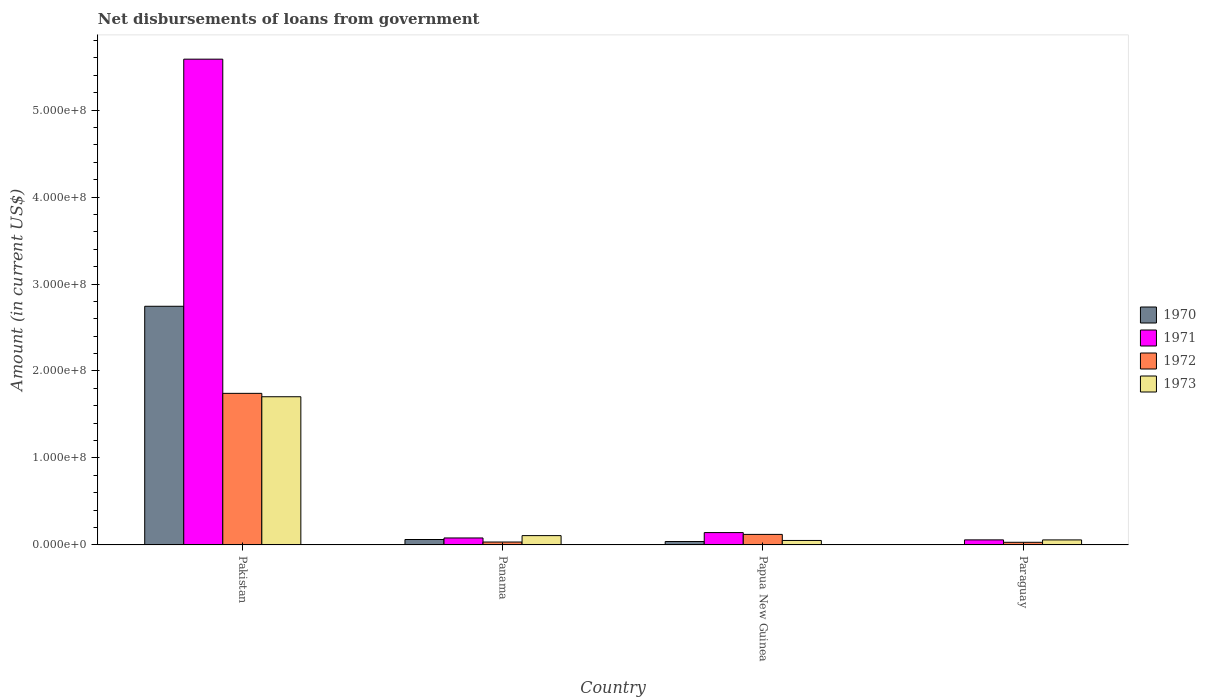How many different coloured bars are there?
Provide a short and direct response. 4. How many groups of bars are there?
Offer a terse response. 4. Are the number of bars on each tick of the X-axis equal?
Keep it short and to the point. Yes. What is the label of the 2nd group of bars from the left?
Provide a short and direct response. Panama. In how many cases, is the number of bars for a given country not equal to the number of legend labels?
Provide a succinct answer. 0. What is the amount of loan disbursed from government in 1970 in Pakistan?
Offer a terse response. 2.74e+08. Across all countries, what is the maximum amount of loan disbursed from government in 1970?
Provide a short and direct response. 2.74e+08. Across all countries, what is the minimum amount of loan disbursed from government in 1971?
Give a very brief answer. 5.80e+06. In which country was the amount of loan disbursed from government in 1971 maximum?
Make the answer very short. Pakistan. In which country was the amount of loan disbursed from government in 1973 minimum?
Provide a short and direct response. Papua New Guinea. What is the total amount of loan disbursed from government in 1973 in the graph?
Give a very brief answer. 1.92e+08. What is the difference between the amount of loan disbursed from government in 1972 in Panama and that in Papua New Guinea?
Your answer should be compact. -8.76e+06. What is the difference between the amount of loan disbursed from government in 1972 in Papua New Guinea and the amount of loan disbursed from government in 1973 in Pakistan?
Give a very brief answer. -1.58e+08. What is the average amount of loan disbursed from government in 1972 per country?
Your answer should be very brief. 4.82e+07. What is the difference between the amount of loan disbursed from government of/in 1970 and amount of loan disbursed from government of/in 1973 in Panama?
Provide a succinct answer. -4.46e+06. In how many countries, is the amount of loan disbursed from government in 1971 greater than 500000000 US$?
Make the answer very short. 1. What is the ratio of the amount of loan disbursed from government in 1971 in Pakistan to that in Paraguay?
Your response must be concise. 96.27. Is the amount of loan disbursed from government in 1970 in Pakistan less than that in Papua New Guinea?
Provide a short and direct response. No. What is the difference between the highest and the second highest amount of loan disbursed from government in 1970?
Provide a short and direct response. 2.70e+08. What is the difference between the highest and the lowest amount of loan disbursed from government in 1970?
Give a very brief answer. 2.74e+08. Is it the case that in every country, the sum of the amount of loan disbursed from government in 1972 and amount of loan disbursed from government in 1973 is greater than the sum of amount of loan disbursed from government in 1971 and amount of loan disbursed from government in 1970?
Your response must be concise. No. What does the 4th bar from the left in Pakistan represents?
Offer a terse response. 1973. Are all the bars in the graph horizontal?
Your answer should be compact. No. How many countries are there in the graph?
Make the answer very short. 4. Are the values on the major ticks of Y-axis written in scientific E-notation?
Provide a short and direct response. Yes. Does the graph contain grids?
Your answer should be very brief. No. Where does the legend appear in the graph?
Give a very brief answer. Center right. What is the title of the graph?
Your answer should be compact. Net disbursements of loans from government. What is the Amount (in current US$) of 1970 in Pakistan?
Offer a very short reply. 2.74e+08. What is the Amount (in current US$) in 1971 in Pakistan?
Provide a short and direct response. 5.59e+08. What is the Amount (in current US$) in 1972 in Pakistan?
Give a very brief answer. 1.74e+08. What is the Amount (in current US$) of 1973 in Pakistan?
Give a very brief answer. 1.70e+08. What is the Amount (in current US$) in 1970 in Panama?
Offer a very short reply. 6.24e+06. What is the Amount (in current US$) of 1971 in Panama?
Offer a terse response. 8.01e+06. What is the Amount (in current US$) in 1972 in Panama?
Ensure brevity in your answer.  3.34e+06. What is the Amount (in current US$) of 1973 in Panama?
Provide a short and direct response. 1.07e+07. What is the Amount (in current US$) in 1970 in Papua New Guinea?
Your answer should be compact. 3.92e+06. What is the Amount (in current US$) in 1971 in Papua New Guinea?
Keep it short and to the point. 1.42e+07. What is the Amount (in current US$) of 1972 in Papua New Guinea?
Your response must be concise. 1.21e+07. What is the Amount (in current US$) in 1973 in Papua New Guinea?
Provide a succinct answer. 5.14e+06. What is the Amount (in current US$) in 1970 in Paraguay?
Ensure brevity in your answer.  3.74e+05. What is the Amount (in current US$) in 1971 in Paraguay?
Give a very brief answer. 5.80e+06. What is the Amount (in current US$) of 1972 in Paraguay?
Your answer should be very brief. 3.04e+06. What is the Amount (in current US$) in 1973 in Paraguay?
Offer a terse response. 5.78e+06. Across all countries, what is the maximum Amount (in current US$) of 1970?
Offer a terse response. 2.74e+08. Across all countries, what is the maximum Amount (in current US$) of 1971?
Your answer should be very brief. 5.59e+08. Across all countries, what is the maximum Amount (in current US$) of 1972?
Provide a short and direct response. 1.74e+08. Across all countries, what is the maximum Amount (in current US$) in 1973?
Give a very brief answer. 1.70e+08. Across all countries, what is the minimum Amount (in current US$) of 1970?
Offer a very short reply. 3.74e+05. Across all countries, what is the minimum Amount (in current US$) in 1971?
Your response must be concise. 5.80e+06. Across all countries, what is the minimum Amount (in current US$) of 1972?
Give a very brief answer. 3.04e+06. Across all countries, what is the minimum Amount (in current US$) in 1973?
Make the answer very short. 5.14e+06. What is the total Amount (in current US$) in 1970 in the graph?
Your response must be concise. 2.85e+08. What is the total Amount (in current US$) in 1971 in the graph?
Offer a terse response. 5.87e+08. What is the total Amount (in current US$) of 1972 in the graph?
Make the answer very short. 1.93e+08. What is the total Amount (in current US$) of 1973 in the graph?
Offer a very short reply. 1.92e+08. What is the difference between the Amount (in current US$) of 1970 in Pakistan and that in Panama?
Offer a terse response. 2.68e+08. What is the difference between the Amount (in current US$) of 1971 in Pakistan and that in Panama?
Your response must be concise. 5.51e+08. What is the difference between the Amount (in current US$) in 1972 in Pakistan and that in Panama?
Ensure brevity in your answer.  1.71e+08. What is the difference between the Amount (in current US$) in 1973 in Pakistan and that in Panama?
Ensure brevity in your answer.  1.60e+08. What is the difference between the Amount (in current US$) in 1970 in Pakistan and that in Papua New Guinea?
Offer a very short reply. 2.70e+08. What is the difference between the Amount (in current US$) of 1971 in Pakistan and that in Papua New Guinea?
Your response must be concise. 5.44e+08. What is the difference between the Amount (in current US$) in 1972 in Pakistan and that in Papua New Guinea?
Provide a succinct answer. 1.62e+08. What is the difference between the Amount (in current US$) of 1973 in Pakistan and that in Papua New Guinea?
Offer a terse response. 1.65e+08. What is the difference between the Amount (in current US$) of 1970 in Pakistan and that in Paraguay?
Make the answer very short. 2.74e+08. What is the difference between the Amount (in current US$) of 1971 in Pakistan and that in Paraguay?
Ensure brevity in your answer.  5.53e+08. What is the difference between the Amount (in current US$) of 1972 in Pakistan and that in Paraguay?
Provide a succinct answer. 1.71e+08. What is the difference between the Amount (in current US$) in 1973 in Pakistan and that in Paraguay?
Offer a very short reply. 1.65e+08. What is the difference between the Amount (in current US$) of 1970 in Panama and that in Papua New Guinea?
Your answer should be compact. 2.32e+06. What is the difference between the Amount (in current US$) in 1971 in Panama and that in Papua New Guinea?
Ensure brevity in your answer.  -6.19e+06. What is the difference between the Amount (in current US$) in 1972 in Panama and that in Papua New Guinea?
Offer a terse response. -8.76e+06. What is the difference between the Amount (in current US$) in 1973 in Panama and that in Papua New Guinea?
Provide a succinct answer. 5.56e+06. What is the difference between the Amount (in current US$) in 1970 in Panama and that in Paraguay?
Make the answer very short. 5.87e+06. What is the difference between the Amount (in current US$) in 1971 in Panama and that in Paraguay?
Make the answer very short. 2.21e+06. What is the difference between the Amount (in current US$) of 1972 in Panama and that in Paraguay?
Provide a succinct answer. 3.09e+05. What is the difference between the Amount (in current US$) of 1973 in Panama and that in Paraguay?
Your response must be concise. 4.92e+06. What is the difference between the Amount (in current US$) in 1970 in Papua New Guinea and that in Paraguay?
Your answer should be compact. 3.55e+06. What is the difference between the Amount (in current US$) of 1971 in Papua New Guinea and that in Paraguay?
Your answer should be compact. 8.40e+06. What is the difference between the Amount (in current US$) in 1972 in Papua New Guinea and that in Paraguay?
Provide a short and direct response. 9.07e+06. What is the difference between the Amount (in current US$) in 1973 in Papua New Guinea and that in Paraguay?
Offer a very short reply. -6.38e+05. What is the difference between the Amount (in current US$) in 1970 in Pakistan and the Amount (in current US$) in 1971 in Panama?
Ensure brevity in your answer.  2.66e+08. What is the difference between the Amount (in current US$) in 1970 in Pakistan and the Amount (in current US$) in 1972 in Panama?
Provide a succinct answer. 2.71e+08. What is the difference between the Amount (in current US$) in 1970 in Pakistan and the Amount (in current US$) in 1973 in Panama?
Your answer should be compact. 2.64e+08. What is the difference between the Amount (in current US$) of 1971 in Pakistan and the Amount (in current US$) of 1972 in Panama?
Provide a short and direct response. 5.55e+08. What is the difference between the Amount (in current US$) of 1971 in Pakistan and the Amount (in current US$) of 1973 in Panama?
Offer a very short reply. 5.48e+08. What is the difference between the Amount (in current US$) of 1972 in Pakistan and the Amount (in current US$) of 1973 in Panama?
Offer a very short reply. 1.64e+08. What is the difference between the Amount (in current US$) in 1970 in Pakistan and the Amount (in current US$) in 1971 in Papua New Guinea?
Give a very brief answer. 2.60e+08. What is the difference between the Amount (in current US$) in 1970 in Pakistan and the Amount (in current US$) in 1972 in Papua New Guinea?
Your answer should be compact. 2.62e+08. What is the difference between the Amount (in current US$) in 1970 in Pakistan and the Amount (in current US$) in 1973 in Papua New Guinea?
Offer a terse response. 2.69e+08. What is the difference between the Amount (in current US$) in 1971 in Pakistan and the Amount (in current US$) in 1972 in Papua New Guinea?
Your response must be concise. 5.46e+08. What is the difference between the Amount (in current US$) of 1971 in Pakistan and the Amount (in current US$) of 1973 in Papua New Guinea?
Your answer should be compact. 5.53e+08. What is the difference between the Amount (in current US$) of 1972 in Pakistan and the Amount (in current US$) of 1973 in Papua New Guinea?
Offer a very short reply. 1.69e+08. What is the difference between the Amount (in current US$) in 1970 in Pakistan and the Amount (in current US$) in 1971 in Paraguay?
Your answer should be very brief. 2.69e+08. What is the difference between the Amount (in current US$) of 1970 in Pakistan and the Amount (in current US$) of 1972 in Paraguay?
Offer a terse response. 2.71e+08. What is the difference between the Amount (in current US$) in 1970 in Pakistan and the Amount (in current US$) in 1973 in Paraguay?
Your response must be concise. 2.69e+08. What is the difference between the Amount (in current US$) in 1971 in Pakistan and the Amount (in current US$) in 1972 in Paraguay?
Your answer should be very brief. 5.56e+08. What is the difference between the Amount (in current US$) in 1971 in Pakistan and the Amount (in current US$) in 1973 in Paraguay?
Provide a short and direct response. 5.53e+08. What is the difference between the Amount (in current US$) of 1972 in Pakistan and the Amount (in current US$) of 1973 in Paraguay?
Keep it short and to the point. 1.69e+08. What is the difference between the Amount (in current US$) of 1970 in Panama and the Amount (in current US$) of 1971 in Papua New Guinea?
Offer a terse response. -7.96e+06. What is the difference between the Amount (in current US$) of 1970 in Panama and the Amount (in current US$) of 1972 in Papua New Guinea?
Keep it short and to the point. -5.86e+06. What is the difference between the Amount (in current US$) in 1970 in Panama and the Amount (in current US$) in 1973 in Papua New Guinea?
Provide a short and direct response. 1.10e+06. What is the difference between the Amount (in current US$) in 1971 in Panama and the Amount (in current US$) in 1972 in Papua New Guinea?
Provide a short and direct response. -4.09e+06. What is the difference between the Amount (in current US$) of 1971 in Panama and the Amount (in current US$) of 1973 in Papua New Guinea?
Make the answer very short. 2.87e+06. What is the difference between the Amount (in current US$) of 1972 in Panama and the Amount (in current US$) of 1973 in Papua New Guinea?
Give a very brief answer. -1.79e+06. What is the difference between the Amount (in current US$) in 1970 in Panama and the Amount (in current US$) in 1972 in Paraguay?
Offer a terse response. 3.21e+06. What is the difference between the Amount (in current US$) of 1970 in Panama and the Amount (in current US$) of 1973 in Paraguay?
Provide a short and direct response. 4.65e+05. What is the difference between the Amount (in current US$) of 1971 in Panama and the Amount (in current US$) of 1972 in Paraguay?
Give a very brief answer. 4.97e+06. What is the difference between the Amount (in current US$) of 1971 in Panama and the Amount (in current US$) of 1973 in Paraguay?
Offer a terse response. 2.23e+06. What is the difference between the Amount (in current US$) of 1972 in Panama and the Amount (in current US$) of 1973 in Paraguay?
Your response must be concise. -2.43e+06. What is the difference between the Amount (in current US$) in 1970 in Papua New Guinea and the Amount (in current US$) in 1971 in Paraguay?
Give a very brief answer. -1.88e+06. What is the difference between the Amount (in current US$) of 1970 in Papua New Guinea and the Amount (in current US$) of 1972 in Paraguay?
Keep it short and to the point. 8.84e+05. What is the difference between the Amount (in current US$) in 1970 in Papua New Guinea and the Amount (in current US$) in 1973 in Paraguay?
Your response must be concise. -1.86e+06. What is the difference between the Amount (in current US$) in 1971 in Papua New Guinea and the Amount (in current US$) in 1972 in Paraguay?
Ensure brevity in your answer.  1.12e+07. What is the difference between the Amount (in current US$) of 1971 in Papua New Guinea and the Amount (in current US$) of 1973 in Paraguay?
Your answer should be very brief. 8.42e+06. What is the difference between the Amount (in current US$) of 1972 in Papua New Guinea and the Amount (in current US$) of 1973 in Paraguay?
Provide a short and direct response. 6.33e+06. What is the average Amount (in current US$) of 1970 per country?
Keep it short and to the point. 7.12e+07. What is the average Amount (in current US$) of 1971 per country?
Make the answer very short. 1.47e+08. What is the average Amount (in current US$) of 1972 per country?
Your answer should be very brief. 4.82e+07. What is the average Amount (in current US$) of 1973 per country?
Your answer should be very brief. 4.80e+07. What is the difference between the Amount (in current US$) in 1970 and Amount (in current US$) in 1971 in Pakistan?
Give a very brief answer. -2.84e+08. What is the difference between the Amount (in current US$) in 1970 and Amount (in current US$) in 1972 in Pakistan?
Make the answer very short. 1.00e+08. What is the difference between the Amount (in current US$) of 1970 and Amount (in current US$) of 1973 in Pakistan?
Offer a terse response. 1.04e+08. What is the difference between the Amount (in current US$) of 1971 and Amount (in current US$) of 1972 in Pakistan?
Make the answer very short. 3.84e+08. What is the difference between the Amount (in current US$) of 1971 and Amount (in current US$) of 1973 in Pakistan?
Provide a short and direct response. 3.88e+08. What is the difference between the Amount (in current US$) in 1972 and Amount (in current US$) in 1973 in Pakistan?
Ensure brevity in your answer.  3.90e+06. What is the difference between the Amount (in current US$) in 1970 and Amount (in current US$) in 1971 in Panama?
Provide a short and direct response. -1.77e+06. What is the difference between the Amount (in current US$) of 1970 and Amount (in current US$) of 1972 in Panama?
Your response must be concise. 2.90e+06. What is the difference between the Amount (in current US$) in 1970 and Amount (in current US$) in 1973 in Panama?
Provide a short and direct response. -4.46e+06. What is the difference between the Amount (in current US$) in 1971 and Amount (in current US$) in 1972 in Panama?
Your answer should be compact. 4.66e+06. What is the difference between the Amount (in current US$) in 1971 and Amount (in current US$) in 1973 in Panama?
Provide a short and direct response. -2.69e+06. What is the difference between the Amount (in current US$) in 1972 and Amount (in current US$) in 1973 in Panama?
Provide a short and direct response. -7.36e+06. What is the difference between the Amount (in current US$) in 1970 and Amount (in current US$) in 1971 in Papua New Guinea?
Keep it short and to the point. -1.03e+07. What is the difference between the Amount (in current US$) in 1970 and Amount (in current US$) in 1972 in Papua New Guinea?
Offer a very short reply. -8.18e+06. What is the difference between the Amount (in current US$) in 1970 and Amount (in current US$) in 1973 in Papua New Guinea?
Your answer should be compact. -1.22e+06. What is the difference between the Amount (in current US$) in 1971 and Amount (in current US$) in 1972 in Papua New Guinea?
Keep it short and to the point. 2.10e+06. What is the difference between the Amount (in current US$) in 1971 and Amount (in current US$) in 1973 in Papua New Guinea?
Make the answer very short. 9.06e+06. What is the difference between the Amount (in current US$) of 1972 and Amount (in current US$) of 1973 in Papua New Guinea?
Make the answer very short. 6.96e+06. What is the difference between the Amount (in current US$) of 1970 and Amount (in current US$) of 1971 in Paraguay?
Give a very brief answer. -5.43e+06. What is the difference between the Amount (in current US$) in 1970 and Amount (in current US$) in 1972 in Paraguay?
Provide a short and direct response. -2.66e+06. What is the difference between the Amount (in current US$) of 1970 and Amount (in current US$) of 1973 in Paraguay?
Your response must be concise. -5.40e+06. What is the difference between the Amount (in current US$) in 1971 and Amount (in current US$) in 1972 in Paraguay?
Give a very brief answer. 2.77e+06. What is the difference between the Amount (in current US$) of 1971 and Amount (in current US$) of 1973 in Paraguay?
Make the answer very short. 2.50e+04. What is the difference between the Amount (in current US$) in 1972 and Amount (in current US$) in 1973 in Paraguay?
Make the answer very short. -2.74e+06. What is the ratio of the Amount (in current US$) of 1970 in Pakistan to that in Panama?
Provide a succinct answer. 43.96. What is the ratio of the Amount (in current US$) in 1971 in Pakistan to that in Panama?
Give a very brief answer. 69.73. What is the ratio of the Amount (in current US$) in 1972 in Pakistan to that in Panama?
Keep it short and to the point. 52.11. What is the ratio of the Amount (in current US$) of 1973 in Pakistan to that in Panama?
Your answer should be very brief. 15.92. What is the ratio of the Amount (in current US$) of 1970 in Pakistan to that in Papua New Guinea?
Offer a very short reply. 70. What is the ratio of the Amount (in current US$) of 1971 in Pakistan to that in Papua New Guinea?
Offer a very short reply. 39.34. What is the ratio of the Amount (in current US$) of 1972 in Pakistan to that in Papua New Guinea?
Give a very brief answer. 14.4. What is the ratio of the Amount (in current US$) of 1973 in Pakistan to that in Papua New Guinea?
Offer a very short reply. 33.16. What is the ratio of the Amount (in current US$) of 1970 in Pakistan to that in Paraguay?
Provide a succinct answer. 733.72. What is the ratio of the Amount (in current US$) in 1971 in Pakistan to that in Paraguay?
Keep it short and to the point. 96.27. What is the ratio of the Amount (in current US$) in 1972 in Pakistan to that in Paraguay?
Give a very brief answer. 57.41. What is the ratio of the Amount (in current US$) of 1973 in Pakistan to that in Paraguay?
Your answer should be compact. 29.5. What is the ratio of the Amount (in current US$) in 1970 in Panama to that in Papua New Guinea?
Provide a short and direct response. 1.59. What is the ratio of the Amount (in current US$) in 1971 in Panama to that in Papua New Guinea?
Offer a very short reply. 0.56. What is the ratio of the Amount (in current US$) in 1972 in Panama to that in Papua New Guinea?
Keep it short and to the point. 0.28. What is the ratio of the Amount (in current US$) in 1973 in Panama to that in Papua New Guinea?
Provide a short and direct response. 2.08. What is the ratio of the Amount (in current US$) in 1970 in Panama to that in Paraguay?
Provide a short and direct response. 16.69. What is the ratio of the Amount (in current US$) of 1971 in Panama to that in Paraguay?
Your response must be concise. 1.38. What is the ratio of the Amount (in current US$) of 1972 in Panama to that in Paraguay?
Make the answer very short. 1.1. What is the ratio of the Amount (in current US$) in 1973 in Panama to that in Paraguay?
Offer a very short reply. 1.85. What is the ratio of the Amount (in current US$) of 1970 in Papua New Guinea to that in Paraguay?
Offer a very short reply. 10.48. What is the ratio of the Amount (in current US$) in 1971 in Papua New Guinea to that in Paraguay?
Offer a very short reply. 2.45. What is the ratio of the Amount (in current US$) in 1972 in Papua New Guinea to that in Paraguay?
Keep it short and to the point. 3.99. What is the ratio of the Amount (in current US$) of 1973 in Papua New Guinea to that in Paraguay?
Your answer should be compact. 0.89. What is the difference between the highest and the second highest Amount (in current US$) of 1970?
Your answer should be very brief. 2.68e+08. What is the difference between the highest and the second highest Amount (in current US$) of 1971?
Ensure brevity in your answer.  5.44e+08. What is the difference between the highest and the second highest Amount (in current US$) in 1972?
Offer a terse response. 1.62e+08. What is the difference between the highest and the second highest Amount (in current US$) in 1973?
Make the answer very short. 1.60e+08. What is the difference between the highest and the lowest Amount (in current US$) of 1970?
Offer a terse response. 2.74e+08. What is the difference between the highest and the lowest Amount (in current US$) of 1971?
Provide a short and direct response. 5.53e+08. What is the difference between the highest and the lowest Amount (in current US$) of 1972?
Provide a short and direct response. 1.71e+08. What is the difference between the highest and the lowest Amount (in current US$) of 1973?
Offer a terse response. 1.65e+08. 